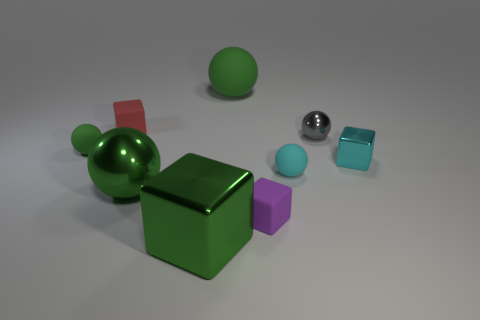Subtract all cyan cylinders. How many green balls are left? 3 Subtract all cyan spheres. How many spheres are left? 4 Subtract all large green metallic balls. How many balls are left? 4 Subtract all red balls. Subtract all red cubes. How many balls are left? 5 Add 1 metal spheres. How many objects exist? 10 Subtract all blocks. How many objects are left? 5 Add 7 tiny green rubber spheres. How many tiny green rubber spheres are left? 8 Add 5 large green balls. How many large green balls exist? 7 Subtract 0 gray cubes. How many objects are left? 9 Subtract all gray objects. Subtract all big brown metal blocks. How many objects are left? 8 